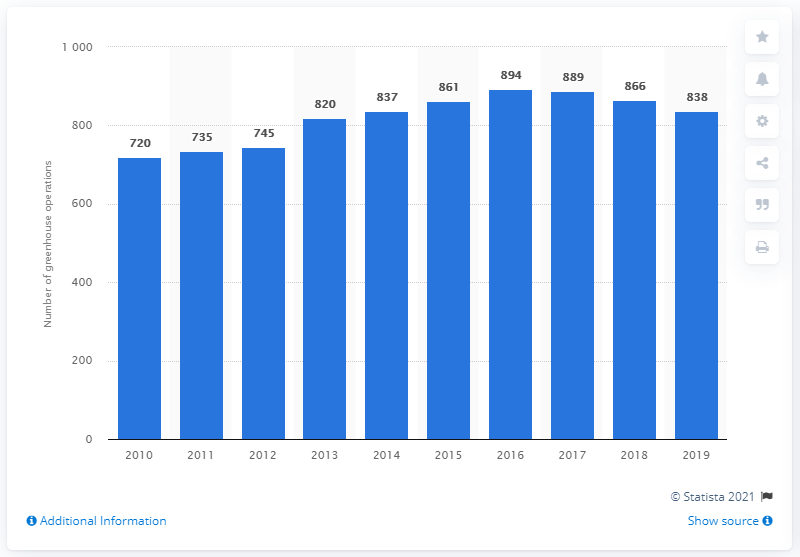Indicate a few pertinent items in this graphic. In 2019, there were 838 greenhouse fruit and vegetable operations in Canada. 